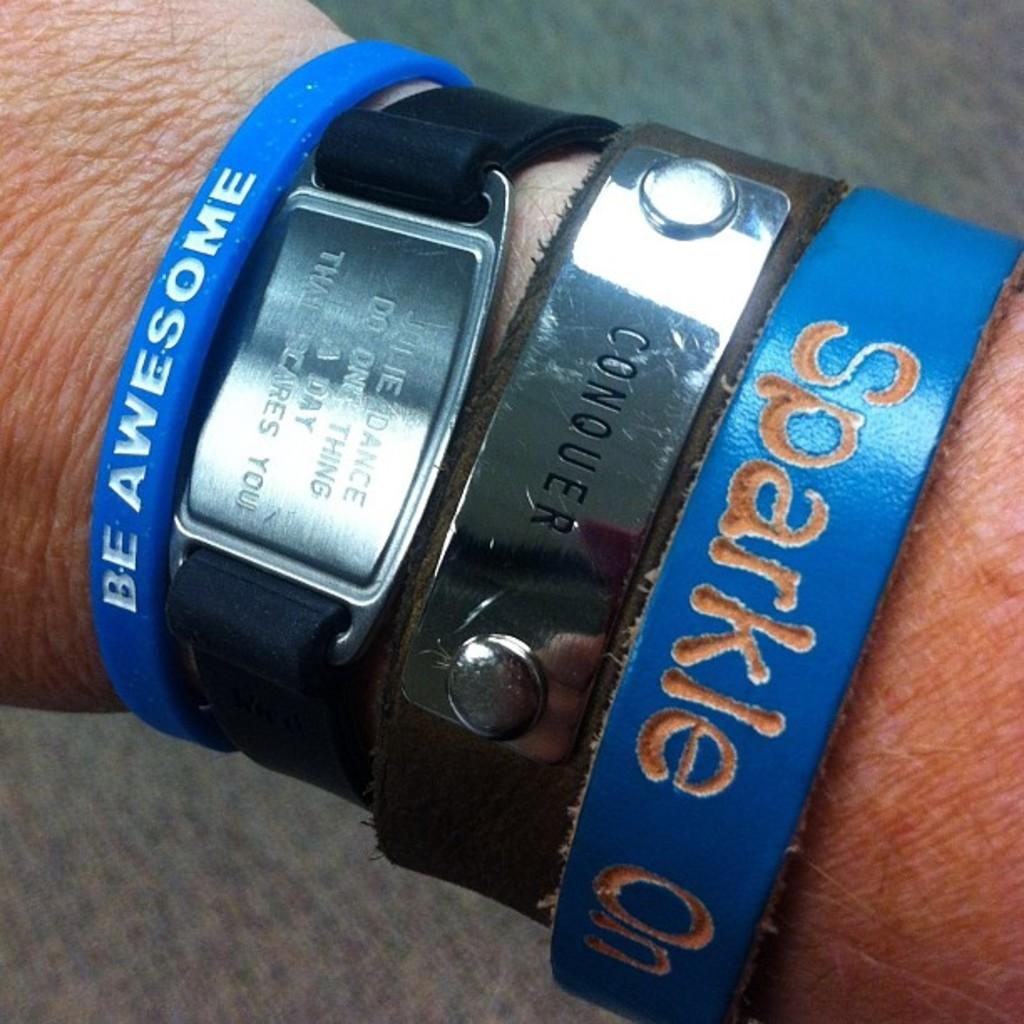Provide a one-sentence caption for the provided image. A person is wearing four different bracelets, all with inspirational sayings on them. 